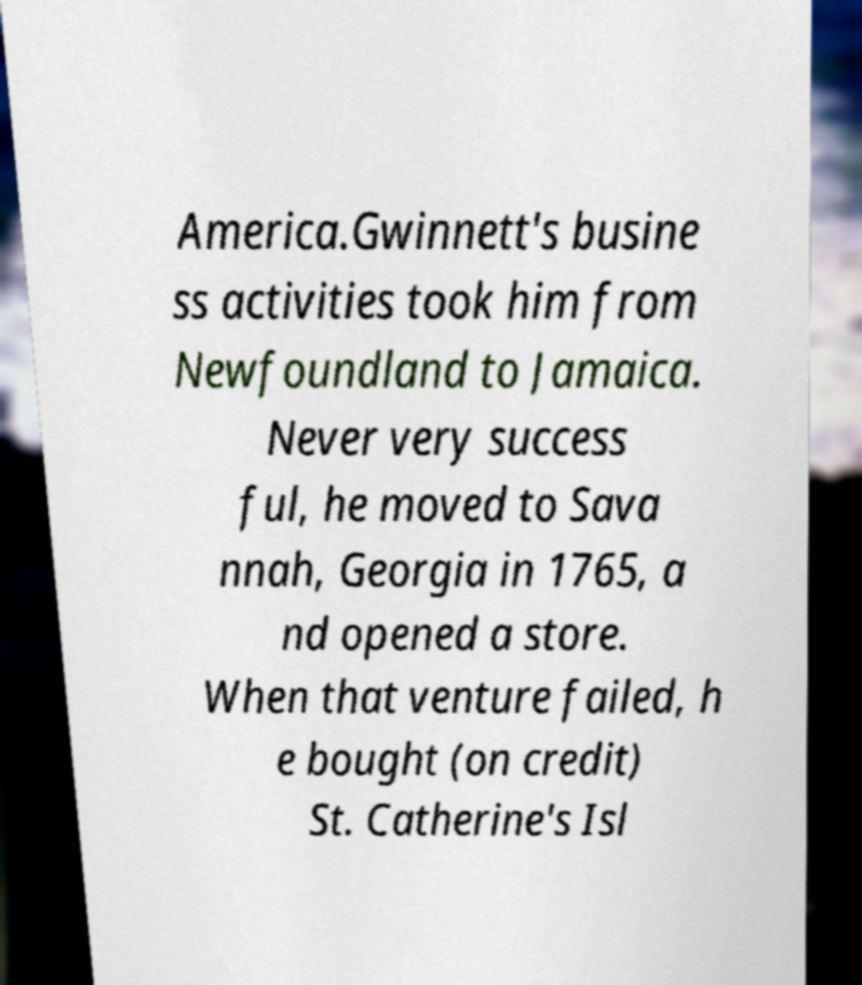For documentation purposes, I need the text within this image transcribed. Could you provide that? America.Gwinnett's busine ss activities took him from Newfoundland to Jamaica. Never very success ful, he moved to Sava nnah, Georgia in 1765, a nd opened a store. When that venture failed, h e bought (on credit) St. Catherine's Isl 